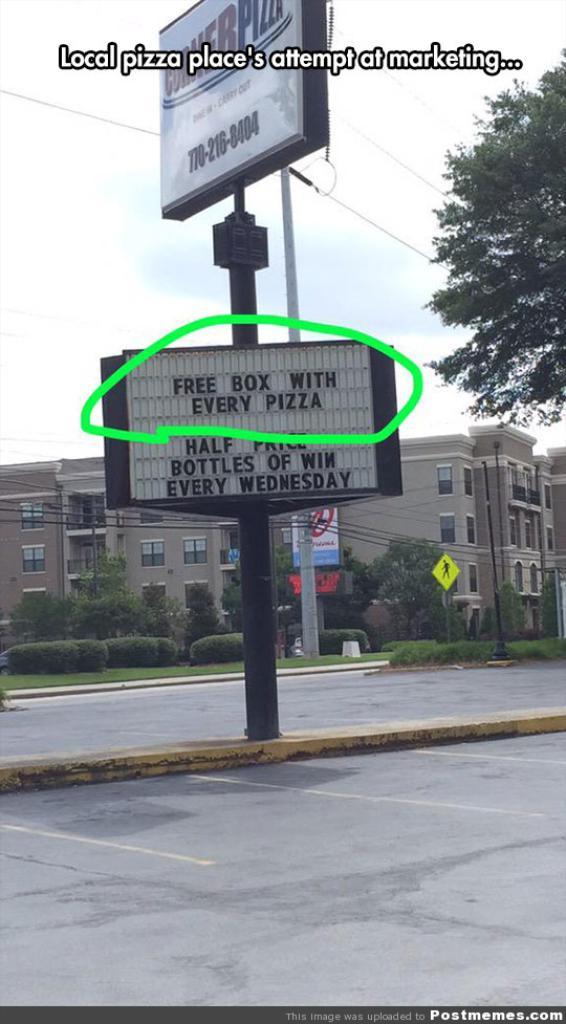What are they advertising?
Provide a succinct answer. Free box with every pizza. What does the caption say?
Make the answer very short. Free box with every pizza. 